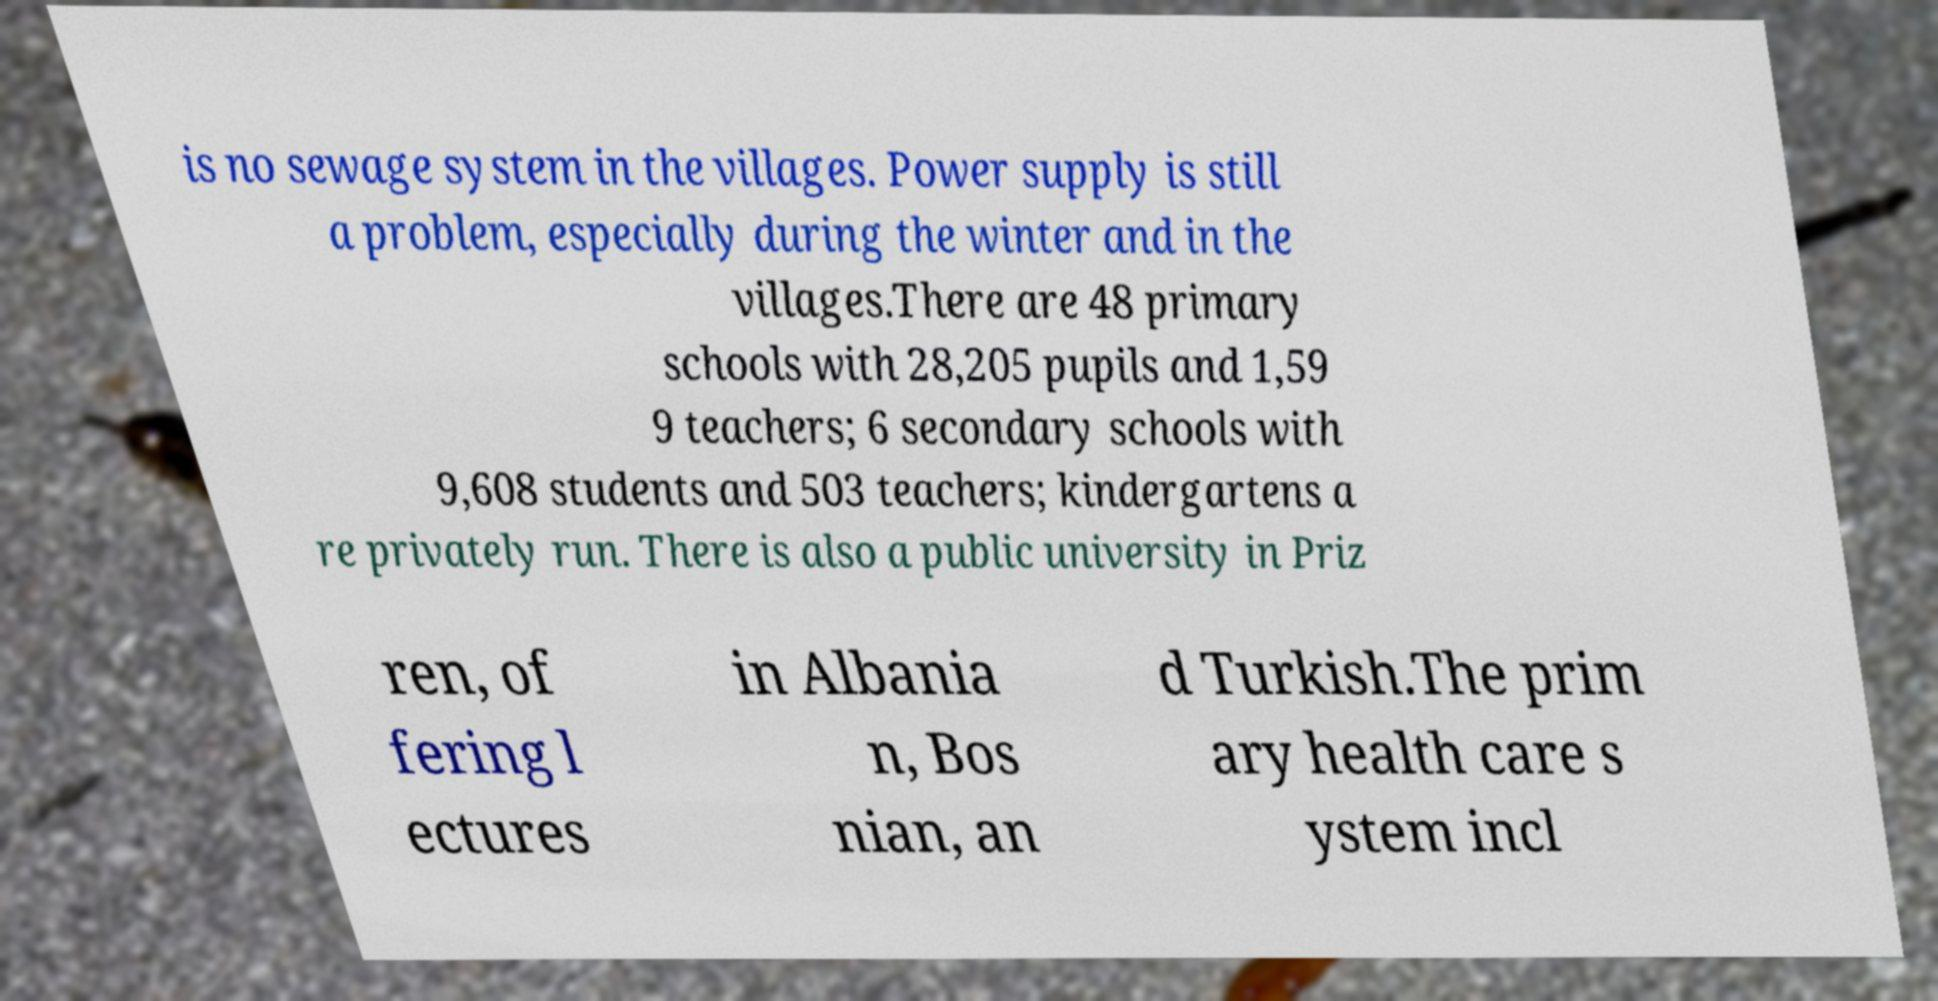Could you assist in decoding the text presented in this image and type it out clearly? is no sewage system in the villages. Power supply is still a problem, especially during the winter and in the villages.There are 48 primary schools with 28,205 pupils and 1,59 9 teachers; 6 secondary schools with 9,608 students and 503 teachers; kindergartens a re privately run. There is also a public university in Priz ren, of fering l ectures in Albania n, Bos nian, an d Turkish.The prim ary health care s ystem incl 